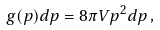<formula> <loc_0><loc_0><loc_500><loc_500>g ( p ) d p = 8 \pi V p ^ { 2 } d p \, ,</formula> 